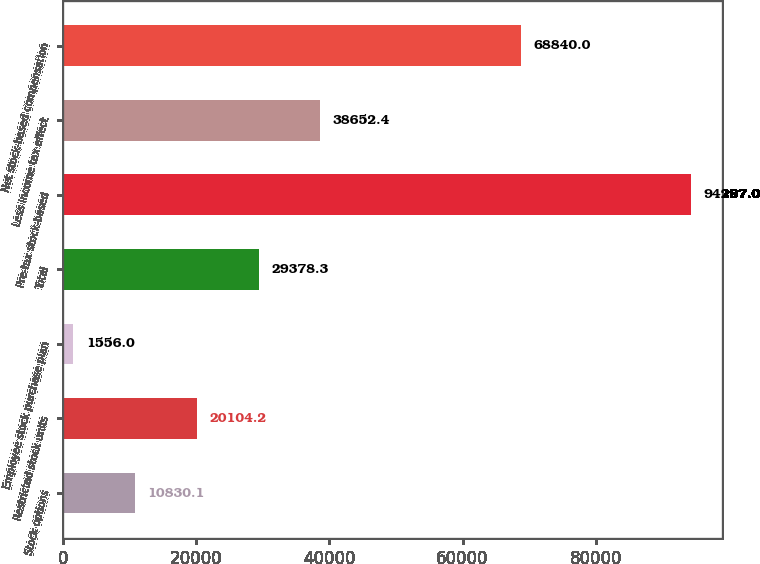Convert chart. <chart><loc_0><loc_0><loc_500><loc_500><bar_chart><fcel>Stock options<fcel>Restricted stock units<fcel>Employee stock purchase plan<fcel>Total<fcel>Pre-tax stock-based<fcel>Less Income tax effect<fcel>Net stock-based compensation<nl><fcel>10830.1<fcel>20104.2<fcel>1556<fcel>29378.3<fcel>94297<fcel>38652.4<fcel>68840<nl></chart> 